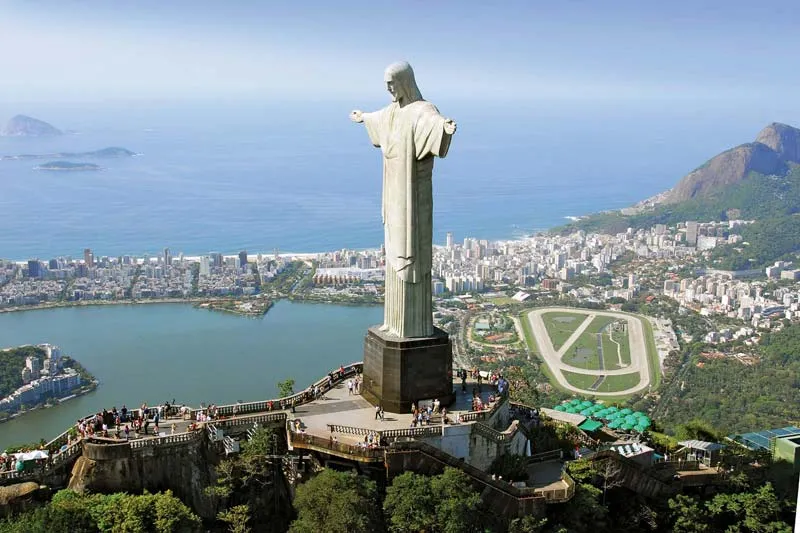What historical significance does this statue hold? The Christ the Redeemer statue is not only an iconic landmark but also a symbol of Christianity across the world. It represents the Brazilian Christian belief and has become an emblem of both Rio de Janeiro and the entire nation's faith and culture. Inaugurated in 1931, the monument was constructed as a plea for peace, commemorating the 100th anniversary of Brazilian independence. It also underscores the art deco movement of its time, combining engineering feats with aesthetic beauty. Recognized the world over, the statue was named one of the New Seven Wonders of the World in 2007, attesting to its cultural and historic stature. 